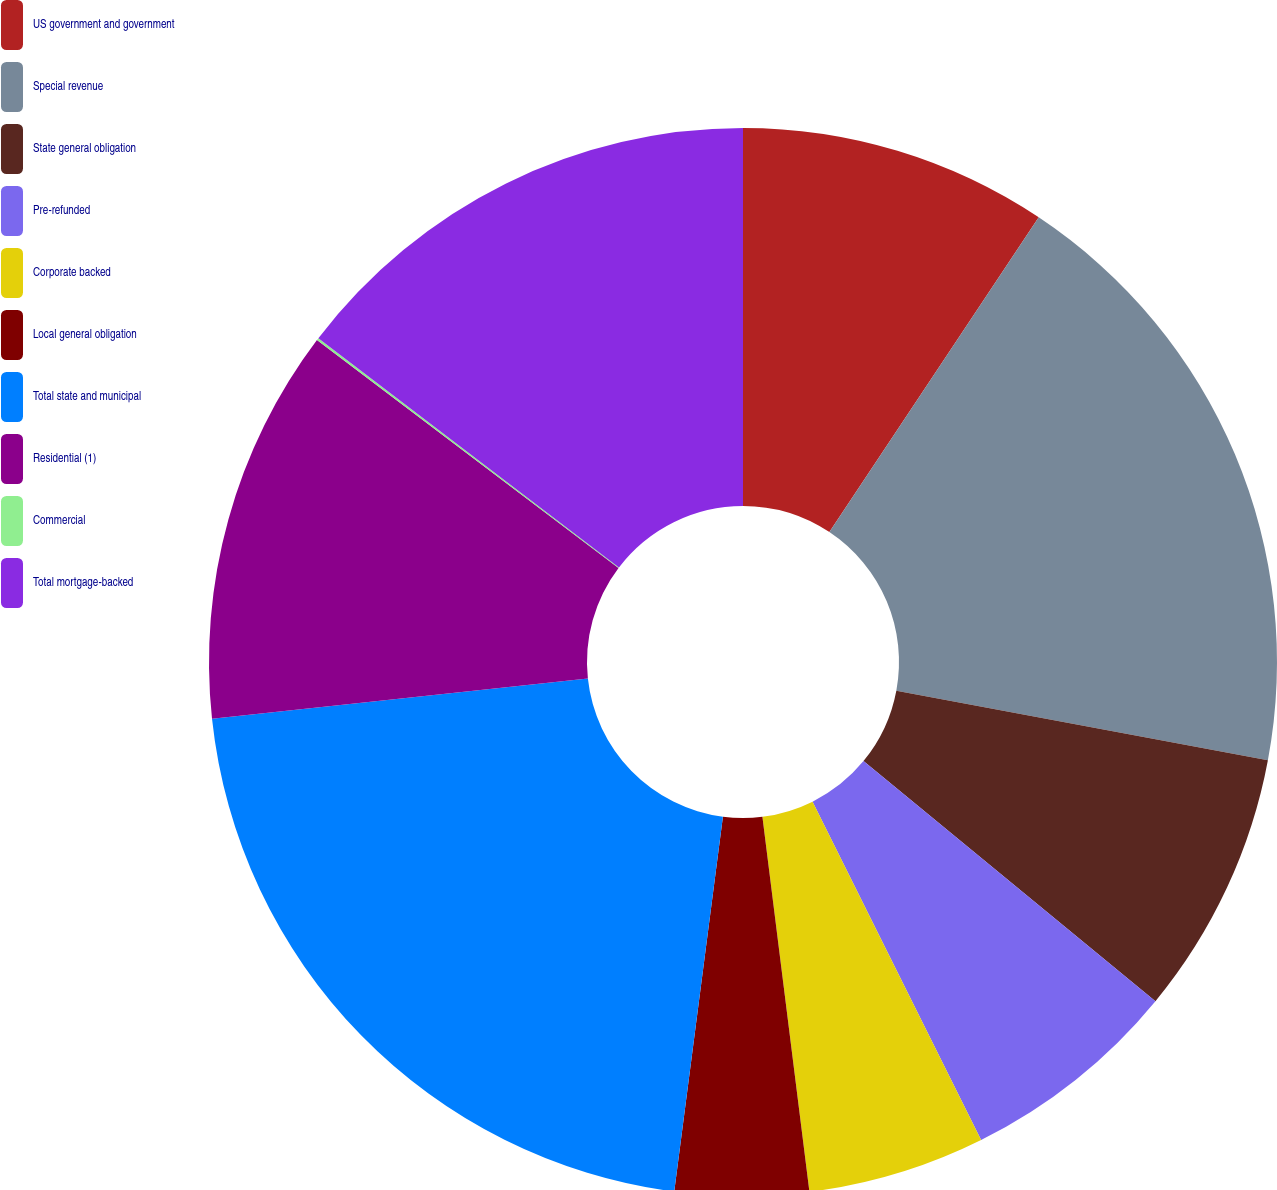Convert chart. <chart><loc_0><loc_0><loc_500><loc_500><pie_chart><fcel>US government and government<fcel>Special revenue<fcel>State general obligation<fcel>Pre-refunded<fcel>Corporate backed<fcel>Local general obligation<fcel>Total state and municipal<fcel>Residential (1)<fcel>Commercial<fcel>Total mortgage-backed<nl><fcel>9.34%<fcel>18.6%<fcel>8.01%<fcel>6.69%<fcel>5.37%<fcel>4.04%<fcel>21.25%<fcel>11.99%<fcel>0.07%<fcel>14.63%<nl></chart> 